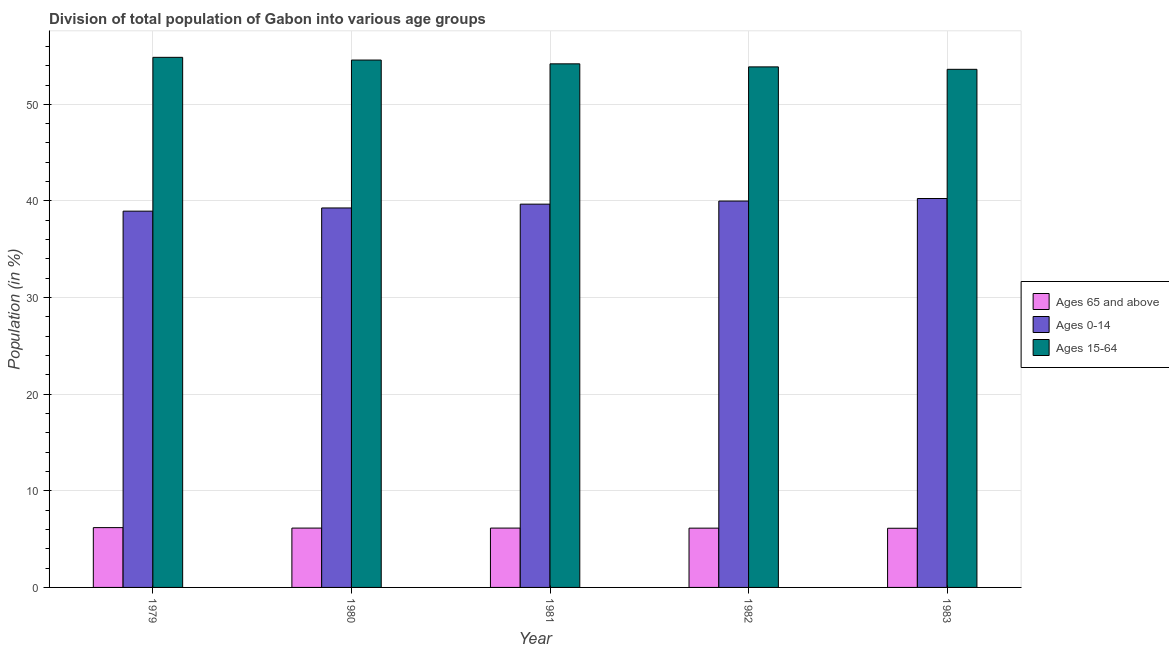Are the number of bars per tick equal to the number of legend labels?
Offer a terse response. Yes. Are the number of bars on each tick of the X-axis equal?
Offer a terse response. Yes. How many bars are there on the 4th tick from the left?
Provide a short and direct response. 3. What is the label of the 3rd group of bars from the left?
Make the answer very short. 1981. What is the percentage of population within the age-group of 65 and above in 1980?
Your answer should be very brief. 6.14. Across all years, what is the maximum percentage of population within the age-group 0-14?
Give a very brief answer. 40.25. Across all years, what is the minimum percentage of population within the age-group of 65 and above?
Provide a short and direct response. 6.12. In which year was the percentage of population within the age-group 15-64 maximum?
Your answer should be very brief. 1979. In which year was the percentage of population within the age-group 0-14 minimum?
Make the answer very short. 1979. What is the total percentage of population within the age-group of 65 and above in the graph?
Keep it short and to the point. 30.73. What is the difference between the percentage of population within the age-group 0-14 in 1979 and that in 1983?
Keep it short and to the point. -1.31. What is the difference between the percentage of population within the age-group of 65 and above in 1980 and the percentage of population within the age-group 15-64 in 1981?
Your response must be concise. 0. What is the average percentage of population within the age-group 0-14 per year?
Offer a terse response. 39.63. In the year 1981, what is the difference between the percentage of population within the age-group 0-14 and percentage of population within the age-group 15-64?
Provide a short and direct response. 0. What is the ratio of the percentage of population within the age-group of 65 and above in 1982 to that in 1983?
Your answer should be compact. 1. What is the difference between the highest and the second highest percentage of population within the age-group 0-14?
Your answer should be very brief. 0.26. What is the difference between the highest and the lowest percentage of population within the age-group of 65 and above?
Ensure brevity in your answer.  0.07. In how many years, is the percentage of population within the age-group of 65 and above greater than the average percentage of population within the age-group of 65 and above taken over all years?
Make the answer very short. 1. Is the sum of the percentage of population within the age-group of 65 and above in 1979 and 1981 greater than the maximum percentage of population within the age-group 0-14 across all years?
Your answer should be very brief. Yes. What does the 1st bar from the left in 1983 represents?
Make the answer very short. Ages 65 and above. What does the 2nd bar from the right in 1979 represents?
Offer a terse response. Ages 0-14. Is it the case that in every year, the sum of the percentage of population within the age-group of 65 and above and percentage of population within the age-group 0-14 is greater than the percentage of population within the age-group 15-64?
Provide a short and direct response. No. How many years are there in the graph?
Give a very brief answer. 5. What is the difference between two consecutive major ticks on the Y-axis?
Keep it short and to the point. 10. Are the values on the major ticks of Y-axis written in scientific E-notation?
Offer a terse response. No. How are the legend labels stacked?
Give a very brief answer. Vertical. What is the title of the graph?
Give a very brief answer. Division of total population of Gabon into various age groups
. What is the Population (in %) in Ages 65 and above in 1979?
Offer a terse response. 6.19. What is the Population (in %) in Ages 0-14 in 1979?
Your answer should be compact. 38.95. What is the Population (in %) in Ages 15-64 in 1979?
Your response must be concise. 54.86. What is the Population (in %) of Ages 65 and above in 1980?
Make the answer very short. 6.14. What is the Population (in %) in Ages 0-14 in 1980?
Keep it short and to the point. 39.27. What is the Population (in %) of Ages 15-64 in 1980?
Ensure brevity in your answer.  54.58. What is the Population (in %) of Ages 65 and above in 1981?
Your answer should be compact. 6.14. What is the Population (in %) in Ages 0-14 in 1981?
Offer a terse response. 39.67. What is the Population (in %) of Ages 15-64 in 1981?
Your answer should be compact. 54.19. What is the Population (in %) in Ages 65 and above in 1982?
Your response must be concise. 6.14. What is the Population (in %) of Ages 0-14 in 1982?
Your answer should be compact. 39.99. What is the Population (in %) of Ages 15-64 in 1982?
Ensure brevity in your answer.  53.88. What is the Population (in %) in Ages 65 and above in 1983?
Provide a succinct answer. 6.12. What is the Population (in %) of Ages 0-14 in 1983?
Your answer should be compact. 40.25. What is the Population (in %) in Ages 15-64 in 1983?
Your response must be concise. 53.62. Across all years, what is the maximum Population (in %) in Ages 65 and above?
Your answer should be compact. 6.19. Across all years, what is the maximum Population (in %) of Ages 0-14?
Offer a very short reply. 40.25. Across all years, what is the maximum Population (in %) in Ages 15-64?
Offer a very short reply. 54.86. Across all years, what is the minimum Population (in %) in Ages 65 and above?
Provide a succinct answer. 6.12. Across all years, what is the minimum Population (in %) of Ages 0-14?
Ensure brevity in your answer.  38.95. Across all years, what is the minimum Population (in %) of Ages 15-64?
Your response must be concise. 53.62. What is the total Population (in %) in Ages 65 and above in the graph?
Keep it short and to the point. 30.73. What is the total Population (in %) in Ages 0-14 in the graph?
Your response must be concise. 198.13. What is the total Population (in %) of Ages 15-64 in the graph?
Give a very brief answer. 271.14. What is the difference between the Population (in %) of Ages 65 and above in 1979 and that in 1980?
Your answer should be very brief. 0.05. What is the difference between the Population (in %) of Ages 0-14 in 1979 and that in 1980?
Your response must be concise. -0.33. What is the difference between the Population (in %) in Ages 15-64 in 1979 and that in 1980?
Your response must be concise. 0.28. What is the difference between the Population (in %) in Ages 65 and above in 1979 and that in 1981?
Your answer should be very brief. 0.05. What is the difference between the Population (in %) in Ages 0-14 in 1979 and that in 1981?
Ensure brevity in your answer.  -0.72. What is the difference between the Population (in %) in Ages 15-64 in 1979 and that in 1981?
Ensure brevity in your answer.  0.67. What is the difference between the Population (in %) of Ages 65 and above in 1979 and that in 1982?
Offer a very short reply. 0.06. What is the difference between the Population (in %) of Ages 0-14 in 1979 and that in 1982?
Keep it short and to the point. -1.04. What is the difference between the Population (in %) of Ages 15-64 in 1979 and that in 1982?
Offer a terse response. 0.99. What is the difference between the Population (in %) of Ages 65 and above in 1979 and that in 1983?
Give a very brief answer. 0.07. What is the difference between the Population (in %) in Ages 0-14 in 1979 and that in 1983?
Provide a short and direct response. -1.31. What is the difference between the Population (in %) in Ages 15-64 in 1979 and that in 1983?
Your response must be concise. 1.24. What is the difference between the Population (in %) in Ages 65 and above in 1980 and that in 1981?
Offer a very short reply. 0. What is the difference between the Population (in %) of Ages 0-14 in 1980 and that in 1981?
Give a very brief answer. -0.39. What is the difference between the Population (in %) in Ages 15-64 in 1980 and that in 1981?
Make the answer very short. 0.39. What is the difference between the Population (in %) of Ages 65 and above in 1980 and that in 1982?
Provide a short and direct response. 0.01. What is the difference between the Population (in %) of Ages 0-14 in 1980 and that in 1982?
Make the answer very short. -0.71. What is the difference between the Population (in %) in Ages 15-64 in 1980 and that in 1982?
Your answer should be very brief. 0.71. What is the difference between the Population (in %) of Ages 65 and above in 1980 and that in 1983?
Give a very brief answer. 0.02. What is the difference between the Population (in %) of Ages 0-14 in 1980 and that in 1983?
Provide a succinct answer. -0.98. What is the difference between the Population (in %) of Ages 15-64 in 1980 and that in 1983?
Make the answer very short. 0.96. What is the difference between the Population (in %) in Ages 65 and above in 1981 and that in 1982?
Your answer should be very brief. 0.01. What is the difference between the Population (in %) of Ages 0-14 in 1981 and that in 1982?
Offer a very short reply. -0.32. What is the difference between the Population (in %) of Ages 15-64 in 1981 and that in 1982?
Keep it short and to the point. 0.31. What is the difference between the Population (in %) of Ages 65 and above in 1981 and that in 1983?
Provide a short and direct response. 0.02. What is the difference between the Population (in %) in Ages 0-14 in 1981 and that in 1983?
Provide a succinct answer. -0.58. What is the difference between the Population (in %) of Ages 15-64 in 1981 and that in 1983?
Keep it short and to the point. 0.57. What is the difference between the Population (in %) of Ages 65 and above in 1982 and that in 1983?
Keep it short and to the point. 0.01. What is the difference between the Population (in %) in Ages 0-14 in 1982 and that in 1983?
Provide a short and direct response. -0.26. What is the difference between the Population (in %) in Ages 15-64 in 1982 and that in 1983?
Make the answer very short. 0.25. What is the difference between the Population (in %) of Ages 65 and above in 1979 and the Population (in %) of Ages 0-14 in 1980?
Your response must be concise. -33.08. What is the difference between the Population (in %) of Ages 65 and above in 1979 and the Population (in %) of Ages 15-64 in 1980?
Your response must be concise. -48.39. What is the difference between the Population (in %) of Ages 0-14 in 1979 and the Population (in %) of Ages 15-64 in 1980?
Offer a very short reply. -15.64. What is the difference between the Population (in %) in Ages 65 and above in 1979 and the Population (in %) in Ages 0-14 in 1981?
Provide a short and direct response. -33.48. What is the difference between the Population (in %) of Ages 65 and above in 1979 and the Population (in %) of Ages 15-64 in 1981?
Offer a very short reply. -48. What is the difference between the Population (in %) in Ages 0-14 in 1979 and the Population (in %) in Ages 15-64 in 1981?
Your answer should be compact. -15.25. What is the difference between the Population (in %) in Ages 65 and above in 1979 and the Population (in %) in Ages 0-14 in 1982?
Give a very brief answer. -33.8. What is the difference between the Population (in %) of Ages 65 and above in 1979 and the Population (in %) of Ages 15-64 in 1982?
Keep it short and to the point. -47.69. What is the difference between the Population (in %) of Ages 0-14 in 1979 and the Population (in %) of Ages 15-64 in 1982?
Provide a short and direct response. -14.93. What is the difference between the Population (in %) in Ages 65 and above in 1979 and the Population (in %) in Ages 0-14 in 1983?
Your response must be concise. -34.06. What is the difference between the Population (in %) in Ages 65 and above in 1979 and the Population (in %) in Ages 15-64 in 1983?
Your response must be concise. -47.43. What is the difference between the Population (in %) of Ages 0-14 in 1979 and the Population (in %) of Ages 15-64 in 1983?
Offer a terse response. -14.68. What is the difference between the Population (in %) in Ages 65 and above in 1980 and the Population (in %) in Ages 0-14 in 1981?
Provide a short and direct response. -33.53. What is the difference between the Population (in %) of Ages 65 and above in 1980 and the Population (in %) of Ages 15-64 in 1981?
Offer a terse response. -48.05. What is the difference between the Population (in %) in Ages 0-14 in 1980 and the Population (in %) in Ages 15-64 in 1981?
Offer a terse response. -14.92. What is the difference between the Population (in %) in Ages 65 and above in 1980 and the Population (in %) in Ages 0-14 in 1982?
Keep it short and to the point. -33.85. What is the difference between the Population (in %) of Ages 65 and above in 1980 and the Population (in %) of Ages 15-64 in 1982?
Provide a short and direct response. -47.73. What is the difference between the Population (in %) of Ages 0-14 in 1980 and the Population (in %) of Ages 15-64 in 1982?
Give a very brief answer. -14.6. What is the difference between the Population (in %) in Ages 65 and above in 1980 and the Population (in %) in Ages 0-14 in 1983?
Give a very brief answer. -34.11. What is the difference between the Population (in %) of Ages 65 and above in 1980 and the Population (in %) of Ages 15-64 in 1983?
Make the answer very short. -47.48. What is the difference between the Population (in %) in Ages 0-14 in 1980 and the Population (in %) in Ages 15-64 in 1983?
Your response must be concise. -14.35. What is the difference between the Population (in %) in Ages 65 and above in 1981 and the Population (in %) in Ages 0-14 in 1982?
Provide a short and direct response. -33.85. What is the difference between the Population (in %) of Ages 65 and above in 1981 and the Population (in %) of Ages 15-64 in 1982?
Provide a short and direct response. -47.73. What is the difference between the Population (in %) in Ages 0-14 in 1981 and the Population (in %) in Ages 15-64 in 1982?
Offer a terse response. -14.21. What is the difference between the Population (in %) in Ages 65 and above in 1981 and the Population (in %) in Ages 0-14 in 1983?
Offer a very short reply. -34.11. What is the difference between the Population (in %) of Ages 65 and above in 1981 and the Population (in %) of Ages 15-64 in 1983?
Make the answer very short. -47.48. What is the difference between the Population (in %) in Ages 0-14 in 1981 and the Population (in %) in Ages 15-64 in 1983?
Provide a short and direct response. -13.96. What is the difference between the Population (in %) of Ages 65 and above in 1982 and the Population (in %) of Ages 0-14 in 1983?
Offer a very short reply. -34.12. What is the difference between the Population (in %) in Ages 65 and above in 1982 and the Population (in %) in Ages 15-64 in 1983?
Make the answer very short. -47.49. What is the difference between the Population (in %) of Ages 0-14 in 1982 and the Population (in %) of Ages 15-64 in 1983?
Your answer should be compact. -13.64. What is the average Population (in %) in Ages 65 and above per year?
Ensure brevity in your answer.  6.15. What is the average Population (in %) of Ages 0-14 per year?
Your answer should be very brief. 39.63. What is the average Population (in %) in Ages 15-64 per year?
Your response must be concise. 54.23. In the year 1979, what is the difference between the Population (in %) of Ages 65 and above and Population (in %) of Ages 0-14?
Ensure brevity in your answer.  -32.75. In the year 1979, what is the difference between the Population (in %) of Ages 65 and above and Population (in %) of Ages 15-64?
Keep it short and to the point. -48.67. In the year 1979, what is the difference between the Population (in %) of Ages 0-14 and Population (in %) of Ages 15-64?
Provide a short and direct response. -15.92. In the year 1980, what is the difference between the Population (in %) of Ages 65 and above and Population (in %) of Ages 0-14?
Your answer should be very brief. -33.13. In the year 1980, what is the difference between the Population (in %) of Ages 65 and above and Population (in %) of Ages 15-64?
Keep it short and to the point. -48.44. In the year 1980, what is the difference between the Population (in %) of Ages 0-14 and Population (in %) of Ages 15-64?
Provide a succinct answer. -15.31. In the year 1981, what is the difference between the Population (in %) of Ages 65 and above and Population (in %) of Ages 0-14?
Your answer should be compact. -33.53. In the year 1981, what is the difference between the Population (in %) of Ages 65 and above and Population (in %) of Ages 15-64?
Offer a terse response. -48.05. In the year 1981, what is the difference between the Population (in %) in Ages 0-14 and Population (in %) in Ages 15-64?
Keep it short and to the point. -14.52. In the year 1982, what is the difference between the Population (in %) in Ages 65 and above and Population (in %) in Ages 0-14?
Ensure brevity in your answer.  -33.85. In the year 1982, what is the difference between the Population (in %) of Ages 65 and above and Population (in %) of Ages 15-64?
Provide a succinct answer. -47.74. In the year 1982, what is the difference between the Population (in %) of Ages 0-14 and Population (in %) of Ages 15-64?
Ensure brevity in your answer.  -13.89. In the year 1983, what is the difference between the Population (in %) in Ages 65 and above and Population (in %) in Ages 0-14?
Provide a short and direct response. -34.13. In the year 1983, what is the difference between the Population (in %) of Ages 65 and above and Population (in %) of Ages 15-64?
Your response must be concise. -47.5. In the year 1983, what is the difference between the Population (in %) of Ages 0-14 and Population (in %) of Ages 15-64?
Keep it short and to the point. -13.37. What is the ratio of the Population (in %) of Ages 65 and above in 1979 to that in 1980?
Offer a very short reply. 1.01. What is the ratio of the Population (in %) of Ages 0-14 in 1979 to that in 1980?
Your answer should be very brief. 0.99. What is the ratio of the Population (in %) of Ages 65 and above in 1979 to that in 1981?
Offer a very short reply. 1.01. What is the ratio of the Population (in %) in Ages 0-14 in 1979 to that in 1981?
Provide a succinct answer. 0.98. What is the ratio of the Population (in %) of Ages 15-64 in 1979 to that in 1981?
Provide a succinct answer. 1.01. What is the ratio of the Population (in %) in Ages 65 and above in 1979 to that in 1982?
Make the answer very short. 1.01. What is the ratio of the Population (in %) in Ages 0-14 in 1979 to that in 1982?
Provide a succinct answer. 0.97. What is the ratio of the Population (in %) of Ages 15-64 in 1979 to that in 1982?
Provide a short and direct response. 1.02. What is the ratio of the Population (in %) of Ages 65 and above in 1979 to that in 1983?
Give a very brief answer. 1.01. What is the ratio of the Population (in %) of Ages 0-14 in 1979 to that in 1983?
Keep it short and to the point. 0.97. What is the ratio of the Population (in %) in Ages 15-64 in 1979 to that in 1983?
Provide a short and direct response. 1.02. What is the ratio of the Population (in %) in Ages 65 and above in 1980 to that in 1981?
Provide a short and direct response. 1. What is the ratio of the Population (in %) in Ages 15-64 in 1980 to that in 1981?
Keep it short and to the point. 1.01. What is the ratio of the Population (in %) of Ages 65 and above in 1980 to that in 1982?
Your answer should be very brief. 1. What is the ratio of the Population (in %) in Ages 0-14 in 1980 to that in 1982?
Offer a very short reply. 0.98. What is the ratio of the Population (in %) of Ages 15-64 in 1980 to that in 1982?
Provide a short and direct response. 1.01. What is the ratio of the Population (in %) of Ages 65 and above in 1980 to that in 1983?
Ensure brevity in your answer.  1. What is the ratio of the Population (in %) in Ages 0-14 in 1980 to that in 1983?
Make the answer very short. 0.98. What is the ratio of the Population (in %) of Ages 15-64 in 1980 to that in 1983?
Your response must be concise. 1.02. What is the ratio of the Population (in %) of Ages 0-14 in 1981 to that in 1982?
Give a very brief answer. 0.99. What is the ratio of the Population (in %) of Ages 15-64 in 1981 to that in 1982?
Provide a succinct answer. 1.01. What is the ratio of the Population (in %) of Ages 65 and above in 1981 to that in 1983?
Make the answer very short. 1. What is the ratio of the Population (in %) of Ages 0-14 in 1981 to that in 1983?
Your response must be concise. 0.99. What is the ratio of the Population (in %) of Ages 15-64 in 1981 to that in 1983?
Ensure brevity in your answer.  1.01. What is the ratio of the Population (in %) of Ages 0-14 in 1982 to that in 1983?
Keep it short and to the point. 0.99. What is the ratio of the Population (in %) of Ages 15-64 in 1982 to that in 1983?
Your response must be concise. 1. What is the difference between the highest and the second highest Population (in %) in Ages 65 and above?
Ensure brevity in your answer.  0.05. What is the difference between the highest and the second highest Population (in %) of Ages 0-14?
Your answer should be very brief. 0.26. What is the difference between the highest and the second highest Population (in %) of Ages 15-64?
Your answer should be very brief. 0.28. What is the difference between the highest and the lowest Population (in %) in Ages 65 and above?
Keep it short and to the point. 0.07. What is the difference between the highest and the lowest Population (in %) in Ages 0-14?
Give a very brief answer. 1.31. What is the difference between the highest and the lowest Population (in %) of Ages 15-64?
Provide a short and direct response. 1.24. 